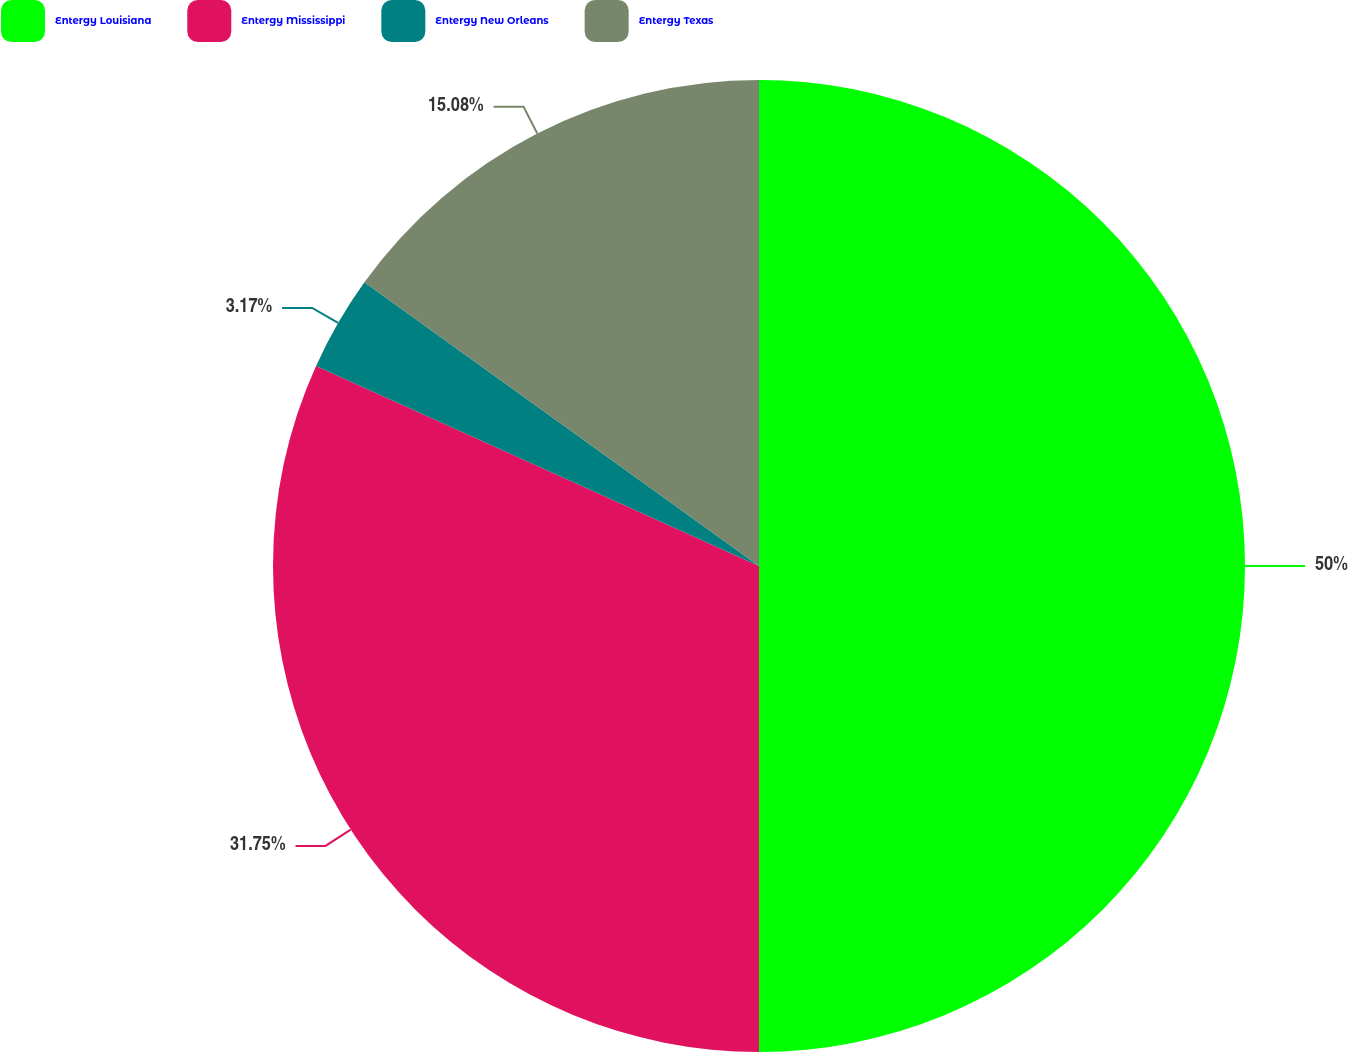Convert chart to OTSL. <chart><loc_0><loc_0><loc_500><loc_500><pie_chart><fcel>Entergy Louisiana<fcel>Entergy Mississippi<fcel>Entergy New Orleans<fcel>Entergy Texas<nl><fcel>50.0%<fcel>31.75%<fcel>3.17%<fcel>15.08%<nl></chart> 